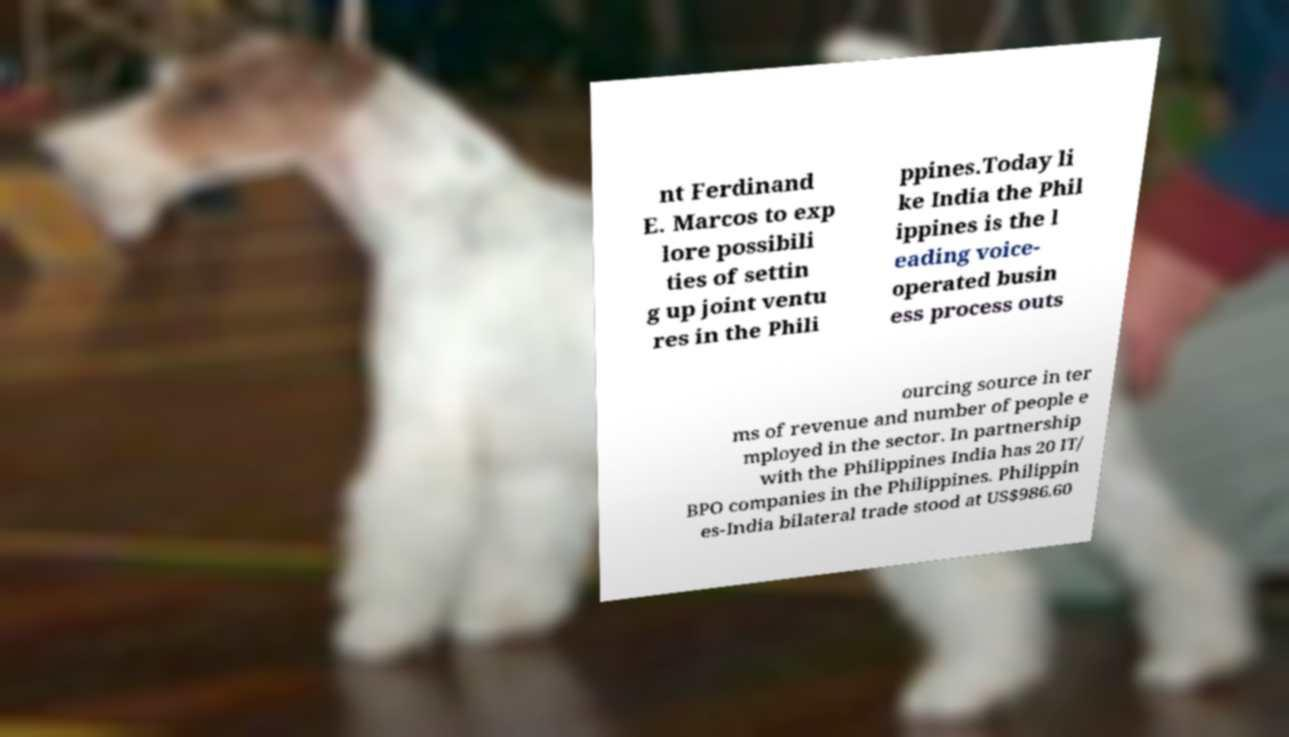Can you read and provide the text displayed in the image?This photo seems to have some interesting text. Can you extract and type it out for me? nt Ferdinand E. Marcos to exp lore possibili ties of settin g up joint ventu res in the Phili ppines.Today li ke India the Phil ippines is the l eading voice- operated busin ess process outs ourcing source in ter ms of revenue and number of people e mployed in the sector. In partnership with the Philippines India has 20 IT/ BPO companies in the Philippines. Philippin es-India bilateral trade stood at US$986.60 